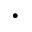Convert formula to latex. <formula><loc_0><loc_0><loc_500><loc_500>\cdot</formula> 